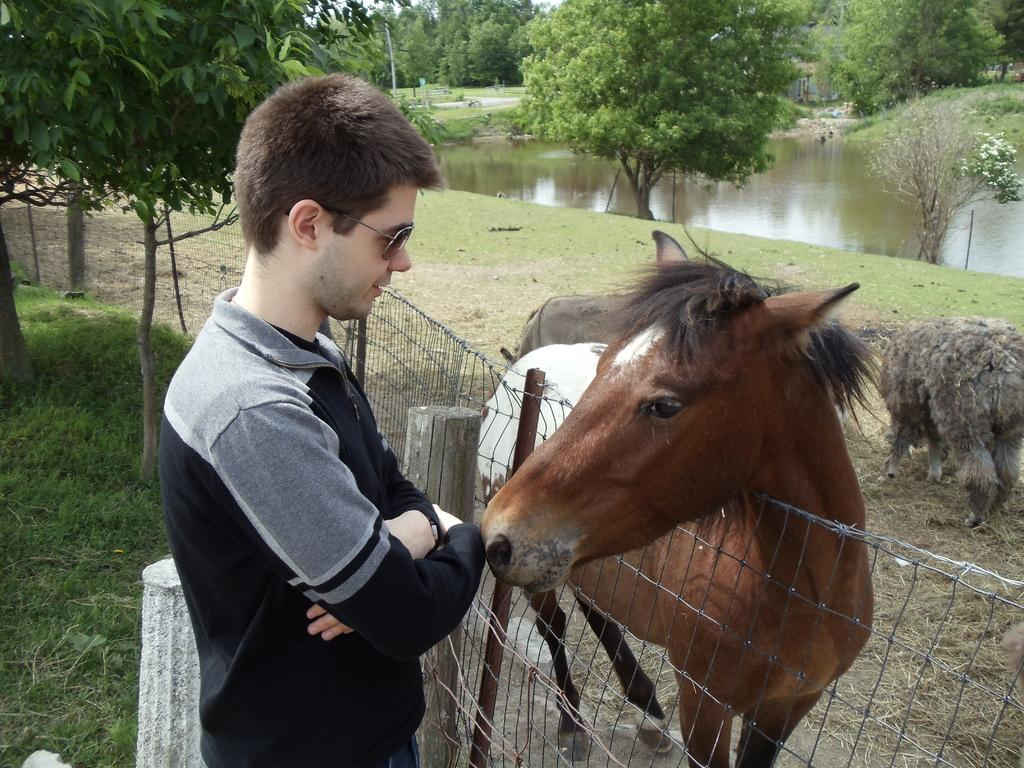What is the person in the image wearing? The person is wearing a black dress in the image. What is the person doing in the image? The person is standing in front of a horse. What separates the person from the horse? There is a fence between the person and the horse. What can be seen in the background of the image? There are trees and a river in the background of the image. What type of underwear is the person wearing in the image? There is no information about the person's underwear in the image, and it cannot be determined from the image. Can you tell me the age of the boy in the image? There is no boy present in the image, only a person standing in front of a horse. 